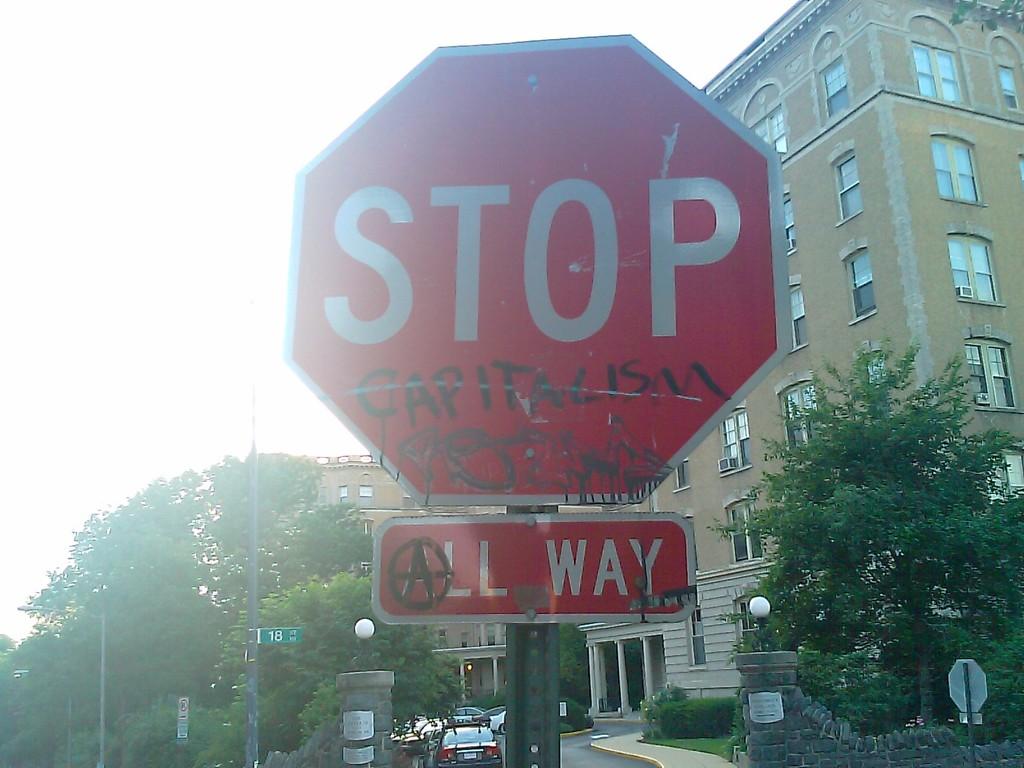What is added beneath the stop sign?
Provide a succinct answer. Capitalism. What is this sign telling you to do?
Keep it short and to the point. Stop. 